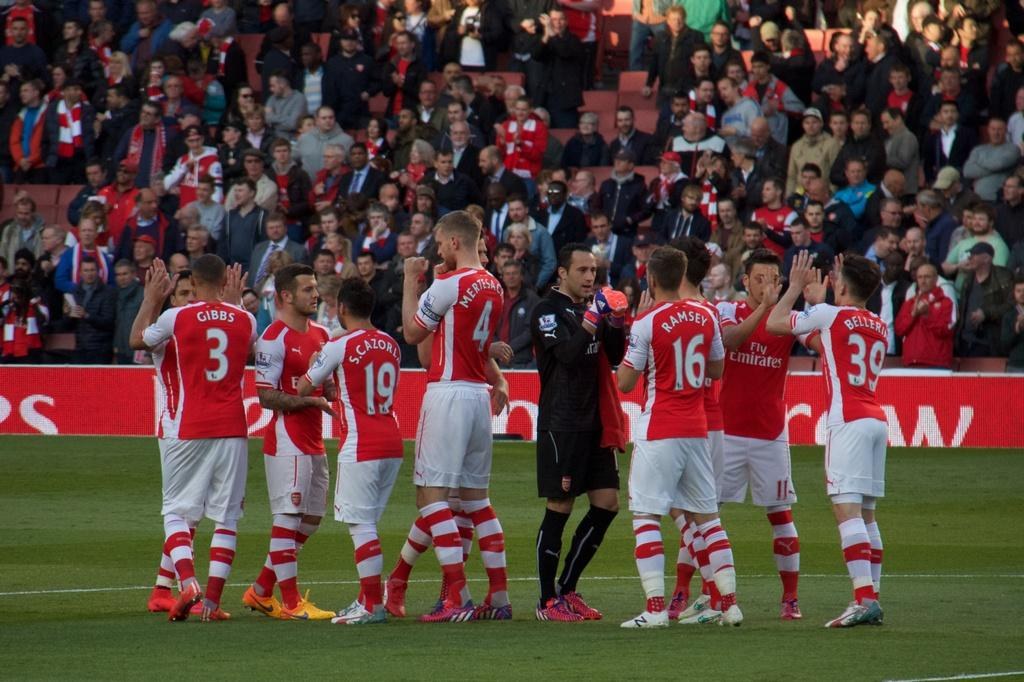Provide a one-sentence caption for the provided image. Players from the Fly Emirates sports team are celebrating on the field. 